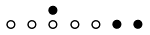<formula> <loc_0><loc_0><loc_500><loc_500>\begin{smallmatrix} & & \bullet \\ \circ & \circ & \circ & \circ & \circ & \bullet & \bullet & \\ \end{smallmatrix}</formula> 